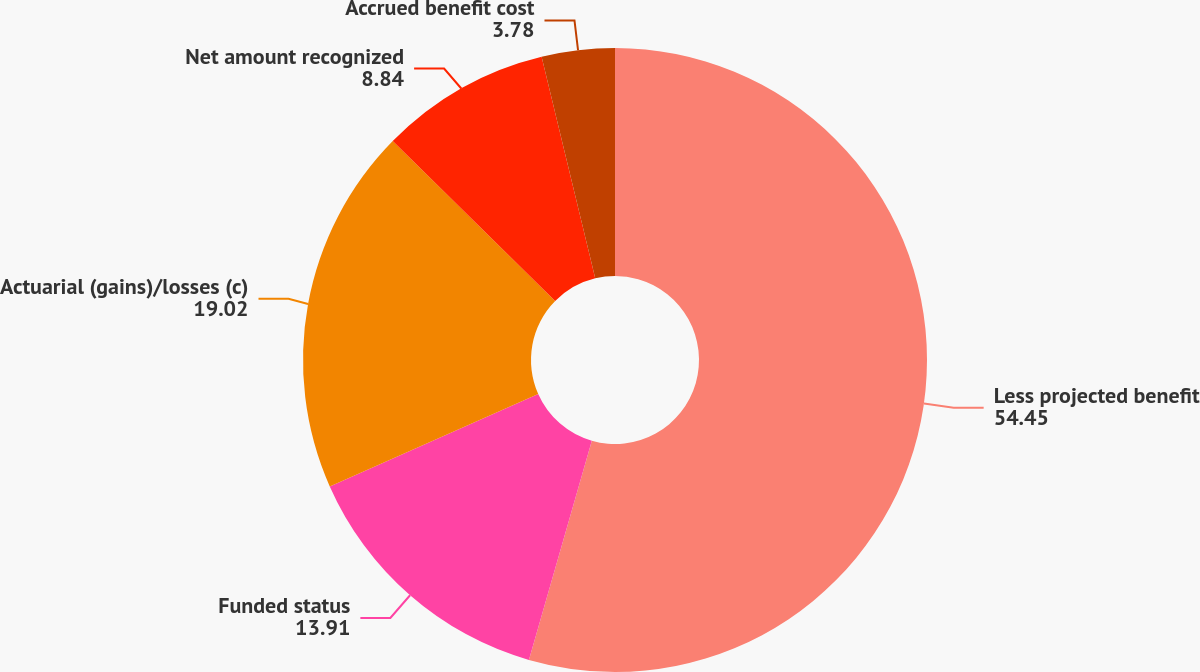Convert chart to OTSL. <chart><loc_0><loc_0><loc_500><loc_500><pie_chart><fcel>Less projected benefit<fcel>Funded status<fcel>Actuarial (gains)/losses (c)<fcel>Net amount recognized<fcel>Accrued benefit cost<nl><fcel>54.45%<fcel>13.91%<fcel>19.02%<fcel>8.84%<fcel>3.78%<nl></chart> 